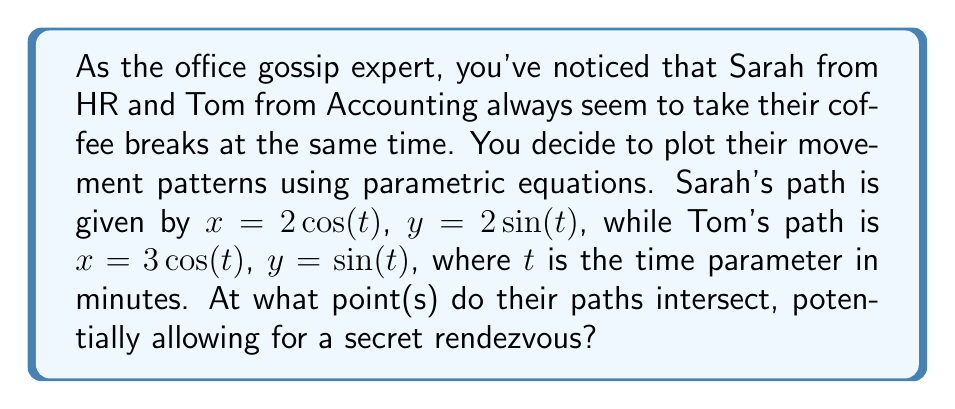Help me with this question. To find the intersection points of Sarah's and Tom's paths, we need to solve the system of equations:

$$\begin{cases}
2\cos(t_1) = 3\cos(t_2) \\
2\sin(t_1) = \sin(t_2)
\end{cases}$$

Where $t_1$ is Sarah's time parameter and $t_2$ is Tom's time parameter.

Step 1: Square both equations and add them:
$$(2\cos(t_1))^2 + (2\sin(t_1))^2 = (3\cos(t_2))^2 + (\sin(t_2))^2$$

Step 2: Simplify using the identity $\cos^2(t) + \sin^2(t) = 1$:
$$4 = 9\cos^2(t_2) + \sin^2(t_2)$$
$$4 = 9\cos^2(t_2) + 1 - \cos^2(t_2)$$
$$3 = 8\cos^2(t_2)$$
$$\cos^2(t_2) = \frac{3}{8}$$

Step 3: Solve for $\cos(t_2)$:
$$\cos(t_2) = \pm\sqrt{\frac{3}{8}} = \pm\frac{\sqrt{3}}{2\sqrt{2}}$$

Step 4: Find $\sin(t_2)$ using $\sin^2(t_2) = 1 - \cos^2(t_2)$:
$$\sin(t_2) = \pm\sqrt{1 - \frac{3}{8}} = \pm\frac{1}{2\sqrt{2}}$$

Step 5: Calculate the intersection points:
For $\cos(t_2) = \frac{\sqrt{3}}{2\sqrt{2}}$ and $\sin(t_2) = \frac{1}{2\sqrt{2}}$:
$$x = 3\cos(t_2) = \frac{3\sqrt{3}}{2\sqrt{2}}, y = \sin(t_2) = \frac{1}{2\sqrt{2}}$$

For $\cos(t_2) = -\frac{\sqrt{3}}{2\sqrt{2}}$ and $\sin(t_2) = -\frac{1}{2\sqrt{2}}$:
$$x = 3\cos(t_2) = -\frac{3\sqrt{3}}{2\sqrt{2}}, y = \sin(t_2) = -\frac{1}{2\sqrt{2}}$$

These are the two intersection points of their paths.
Answer: The paths intersect at two points: $(\frac{3\sqrt{3}}{2\sqrt{2}}, \frac{1}{2\sqrt{2}})$ and $(-\frac{3\sqrt{3}}{2\sqrt{2}}, -\frac{1}{2\sqrt{2}})$. 